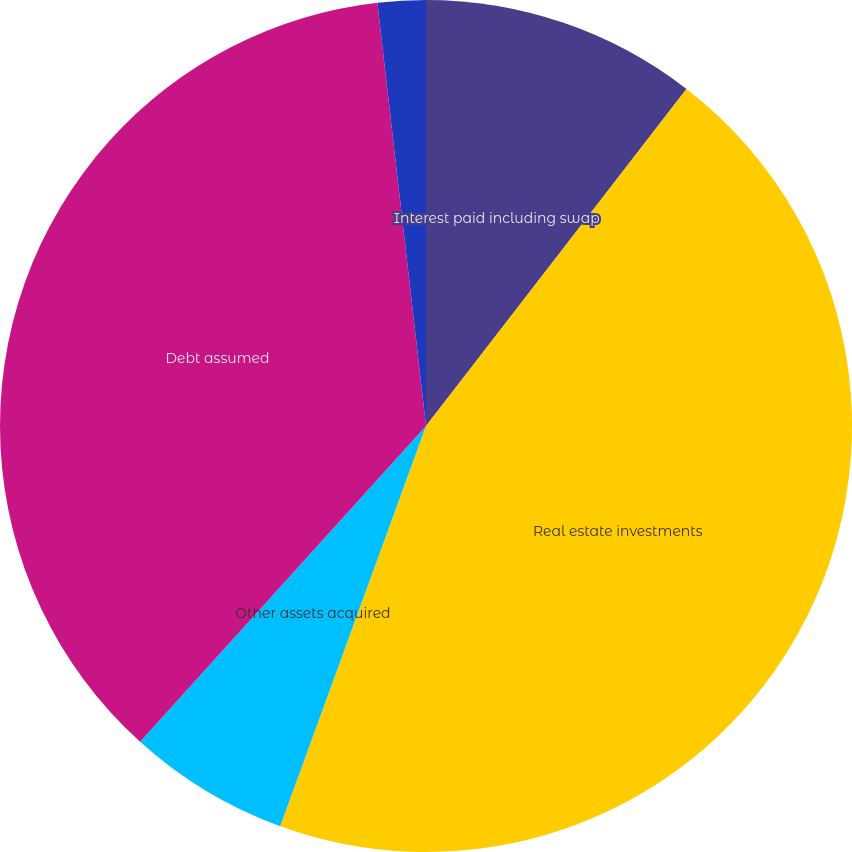<chart> <loc_0><loc_0><loc_500><loc_500><pie_chart><fcel>Interest paid including swap<fcel>Real estate investments<fcel>Other assets acquired<fcel>Debt assumed<fcel>Other liabilities<nl><fcel>10.47%<fcel>45.09%<fcel>6.15%<fcel>36.47%<fcel>1.82%<nl></chart> 